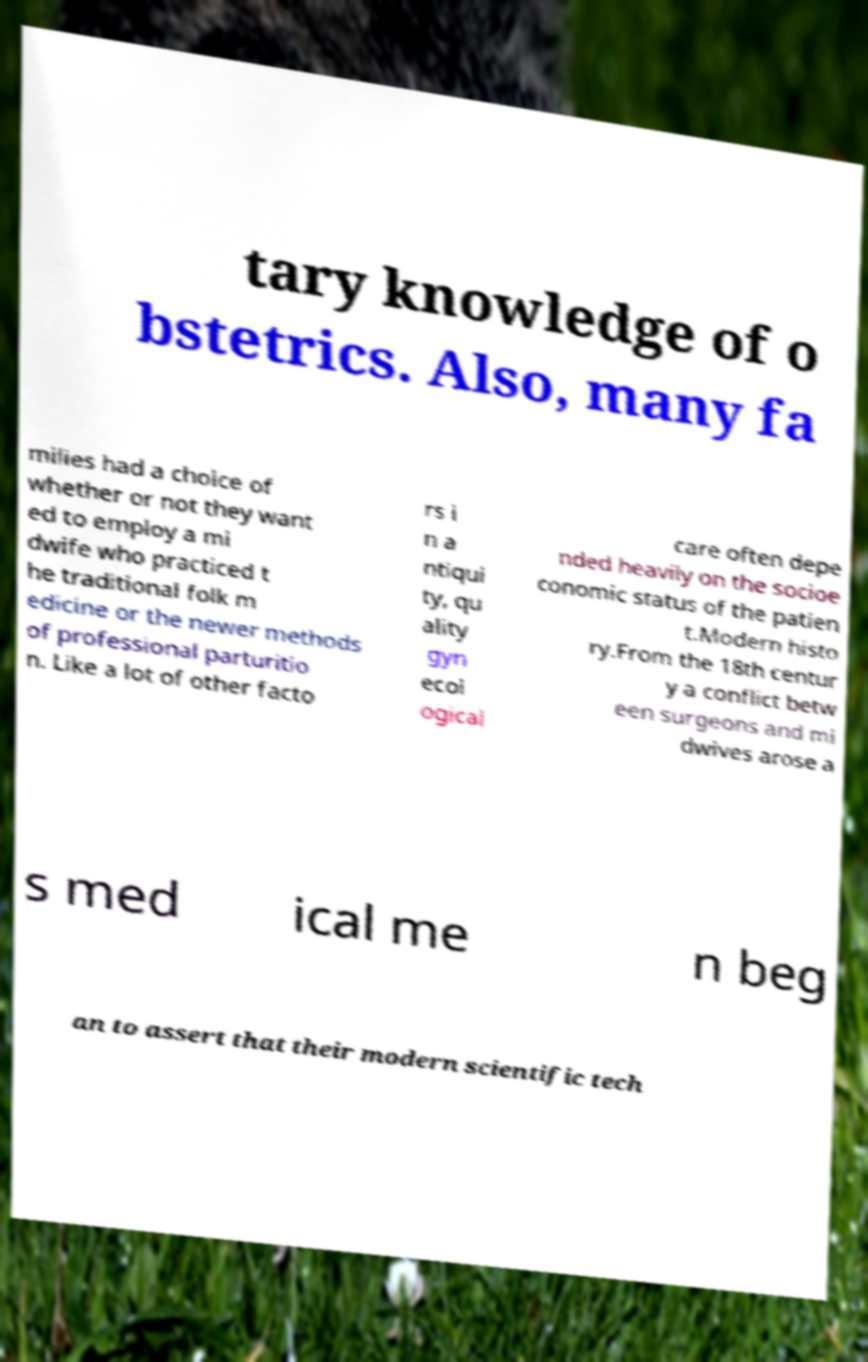I need the written content from this picture converted into text. Can you do that? tary knowledge of o bstetrics. Also, many fa milies had a choice of whether or not they want ed to employ a mi dwife who practiced t he traditional folk m edicine or the newer methods of professional parturitio n. Like a lot of other facto rs i n a ntiqui ty, qu ality gyn ecol ogical care often depe nded heavily on the socioe conomic status of the patien t.Modern histo ry.From the 18th centur y a conflict betw een surgeons and mi dwives arose a s med ical me n beg an to assert that their modern scientific tech 